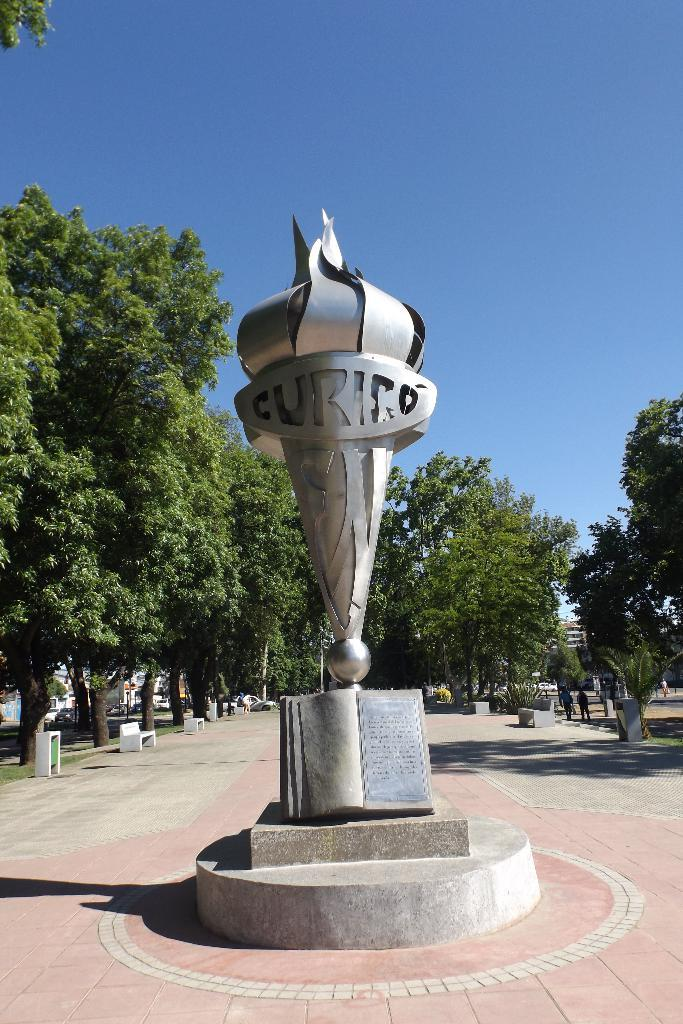<image>
Write a terse but informative summary of the picture. a metal object that says 'curico' on it 